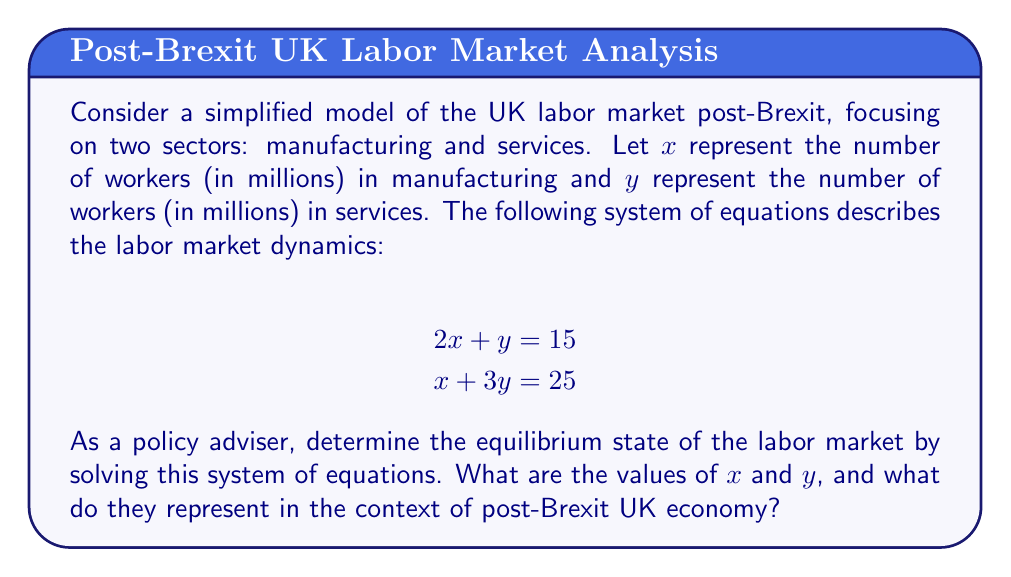Can you solve this math problem? To solve this system of equations and find the equilibrium state of the labor market, we'll use the substitution method:

1. From the first equation, express $y$ in terms of $x$:
   $$2x + y = 15$$
   $$y = 15 - 2x$$

2. Substitute this expression for $y$ into the second equation:
   $$x + 3(15 - 2x) = 25$$

3. Simplify:
   $$x + 45 - 6x = 25$$
   $$45 - 5x = 25$$
   $$-5x = -20$$

4. Solve for $x$:
   $$x = 4$$

5. Substitute $x = 4$ back into the equation for $y$:
   $$y = 15 - 2(4) = 15 - 8 = 7$$

Therefore, the equilibrium state of the labor market is $x = 4$ and $y = 7$.

In the context of the post-Brexit UK economy:
- $x = 4$ represents 4 million workers in the manufacturing sector
- $y = 7$ represents 7 million workers in the services sector

This equilibrium suggests that in the post-Brexit labor market, there is a shift towards the services sector, which is consistent with the long-term trend in developed economies. The manufacturing sector, while smaller, still maintains a significant presence. As a policy adviser, you would need to consider the implications of this distribution on economic growth, trade negotiations, and workforce development strategies.
Answer: The equilibrium state of the labor market is $x = 4$ million workers in manufacturing and $y = 7$ million workers in services. 